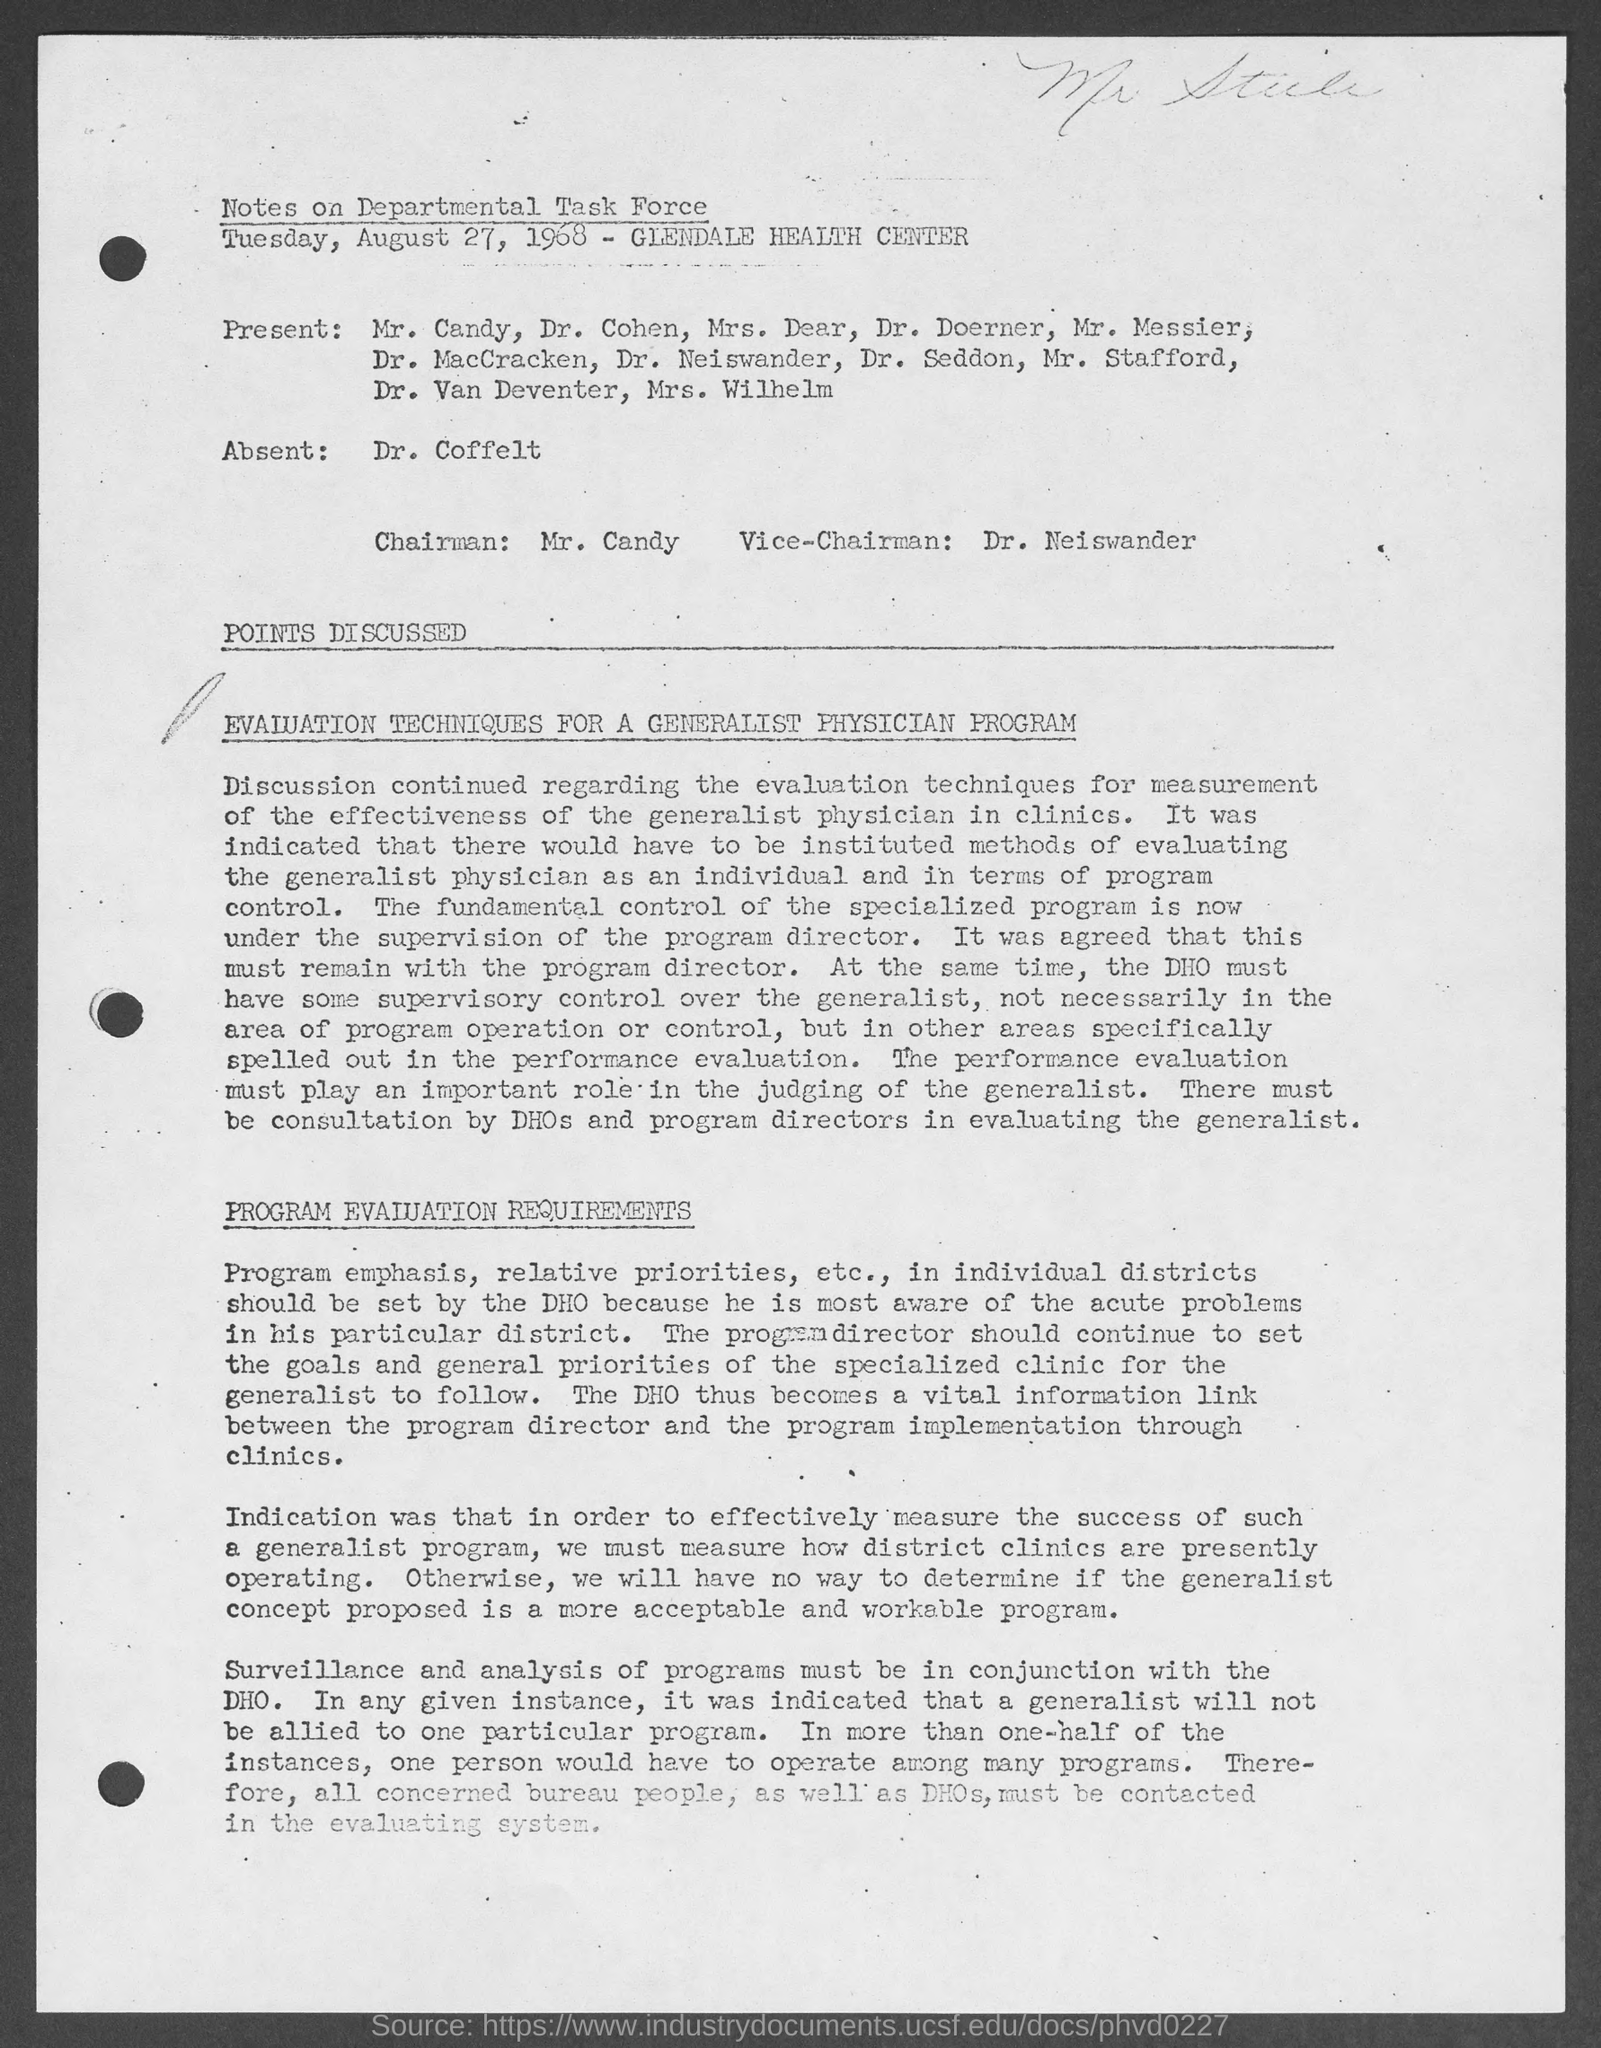Who is the Chairman mentioned in the document?
Keep it short and to the point. MR. CANDY. Who is the Vice-Chairman mentioned in the document?
Give a very brief answer. DR. NEISWANDER. Who was marked absent in the Notes on Departmental Task Force?
Your response must be concise. Dr. Coffelt. What is the date mentioned in this document?
Your answer should be compact. Tuesday, August 27, 1968. 